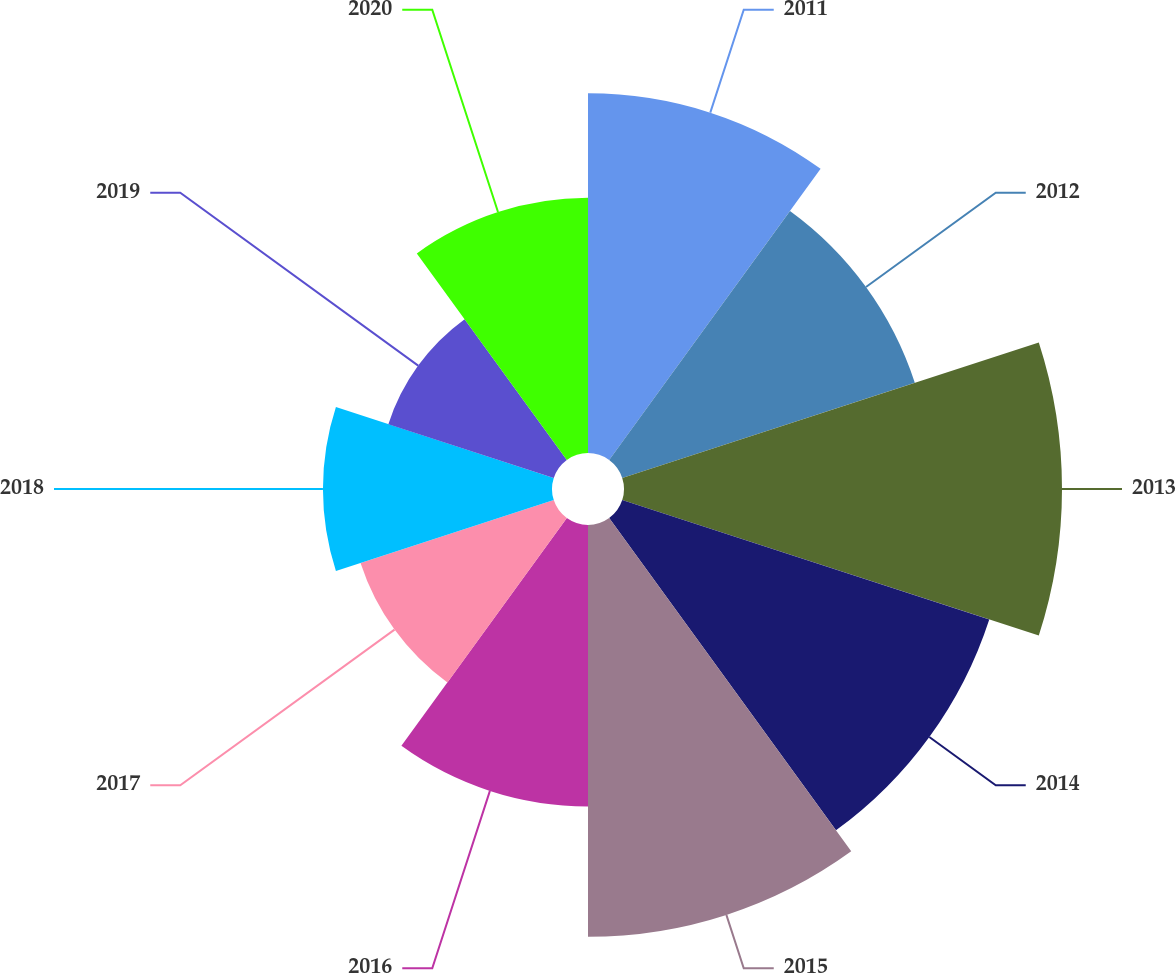<chart> <loc_0><loc_0><loc_500><loc_500><pie_chart><fcel>2011<fcel>2012<fcel>2013<fcel>2014<fcel>2015<fcel>2016<fcel>2017<fcel>2018<fcel>2019<fcel>2020<nl><fcel>11.81%<fcel>10.1%<fcel>14.38%<fcel>12.67%<fcel>13.52%<fcel>9.24%<fcel>6.67%<fcel>7.52%<fcel>5.71%<fcel>8.38%<nl></chart> 